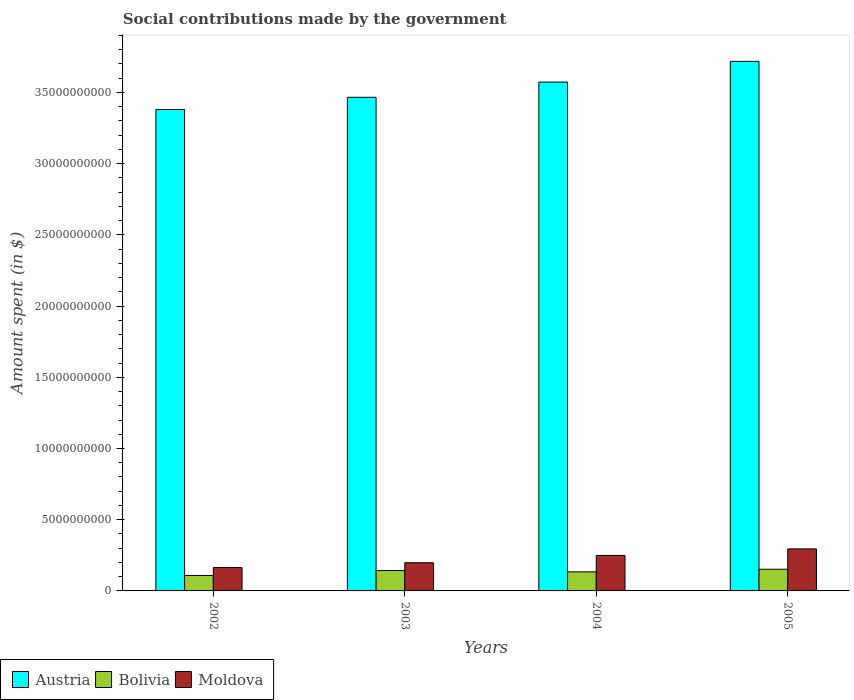How many different coloured bars are there?
Offer a terse response. 3. How many bars are there on the 1st tick from the left?
Make the answer very short. 3. In how many cases, is the number of bars for a given year not equal to the number of legend labels?
Give a very brief answer. 0. What is the amount spent on social contributions in Moldova in 2004?
Give a very brief answer. 2.49e+09. Across all years, what is the maximum amount spent on social contributions in Austria?
Your answer should be very brief. 3.72e+1. Across all years, what is the minimum amount spent on social contributions in Bolivia?
Offer a terse response. 1.08e+09. In which year was the amount spent on social contributions in Bolivia maximum?
Your answer should be compact. 2005. In which year was the amount spent on social contributions in Austria minimum?
Offer a very short reply. 2002. What is the total amount spent on social contributions in Bolivia in the graph?
Keep it short and to the point. 5.38e+09. What is the difference between the amount spent on social contributions in Moldova in 2004 and that in 2005?
Make the answer very short. -4.57e+08. What is the difference between the amount spent on social contributions in Austria in 2003 and the amount spent on social contributions in Bolivia in 2005?
Offer a very short reply. 3.31e+1. What is the average amount spent on social contributions in Moldova per year?
Offer a very short reply. 2.27e+09. In the year 2003, what is the difference between the amount spent on social contributions in Austria and amount spent on social contributions in Moldova?
Offer a terse response. 3.27e+1. What is the ratio of the amount spent on social contributions in Austria in 2002 to that in 2003?
Your response must be concise. 0.98. What is the difference between the highest and the second highest amount spent on social contributions in Bolivia?
Ensure brevity in your answer.  9.23e+07. What is the difference between the highest and the lowest amount spent on social contributions in Moldova?
Provide a succinct answer. 1.31e+09. In how many years, is the amount spent on social contributions in Austria greater than the average amount spent on social contributions in Austria taken over all years?
Offer a very short reply. 2. What does the 1st bar from the right in 2003 represents?
Your answer should be very brief. Moldova. Are all the bars in the graph horizontal?
Your answer should be compact. No. Are the values on the major ticks of Y-axis written in scientific E-notation?
Give a very brief answer. No. Where does the legend appear in the graph?
Offer a very short reply. Bottom left. What is the title of the graph?
Your response must be concise. Social contributions made by the government. What is the label or title of the X-axis?
Provide a succinct answer. Years. What is the label or title of the Y-axis?
Make the answer very short. Amount spent (in $). What is the Amount spent (in $) of Austria in 2002?
Ensure brevity in your answer.  3.38e+1. What is the Amount spent (in $) of Bolivia in 2002?
Your answer should be compact. 1.08e+09. What is the Amount spent (in $) in Moldova in 2002?
Offer a terse response. 1.64e+09. What is the Amount spent (in $) in Austria in 2003?
Make the answer very short. 3.47e+1. What is the Amount spent (in $) in Bolivia in 2003?
Your answer should be compact. 1.43e+09. What is the Amount spent (in $) in Moldova in 2003?
Provide a succinct answer. 1.98e+09. What is the Amount spent (in $) in Austria in 2004?
Provide a succinct answer. 3.57e+1. What is the Amount spent (in $) in Bolivia in 2004?
Offer a very short reply. 1.34e+09. What is the Amount spent (in $) of Moldova in 2004?
Give a very brief answer. 2.49e+09. What is the Amount spent (in $) of Austria in 2005?
Provide a succinct answer. 3.72e+1. What is the Amount spent (in $) of Bolivia in 2005?
Give a very brief answer. 1.52e+09. What is the Amount spent (in $) in Moldova in 2005?
Keep it short and to the point. 2.95e+09. Across all years, what is the maximum Amount spent (in $) of Austria?
Keep it short and to the point. 3.72e+1. Across all years, what is the maximum Amount spent (in $) in Bolivia?
Offer a terse response. 1.52e+09. Across all years, what is the maximum Amount spent (in $) of Moldova?
Ensure brevity in your answer.  2.95e+09. Across all years, what is the minimum Amount spent (in $) of Austria?
Offer a terse response. 3.38e+1. Across all years, what is the minimum Amount spent (in $) in Bolivia?
Your answer should be compact. 1.08e+09. Across all years, what is the minimum Amount spent (in $) in Moldova?
Offer a terse response. 1.64e+09. What is the total Amount spent (in $) of Austria in the graph?
Your answer should be very brief. 1.41e+11. What is the total Amount spent (in $) in Bolivia in the graph?
Ensure brevity in your answer.  5.38e+09. What is the total Amount spent (in $) in Moldova in the graph?
Provide a short and direct response. 9.06e+09. What is the difference between the Amount spent (in $) of Austria in 2002 and that in 2003?
Your answer should be compact. -8.56e+08. What is the difference between the Amount spent (in $) of Bolivia in 2002 and that in 2003?
Your response must be concise. -3.46e+08. What is the difference between the Amount spent (in $) of Moldova in 2002 and that in 2003?
Your answer should be very brief. -3.34e+08. What is the difference between the Amount spent (in $) of Austria in 2002 and that in 2004?
Give a very brief answer. -1.92e+09. What is the difference between the Amount spent (in $) of Bolivia in 2002 and that in 2004?
Your answer should be very brief. -2.54e+08. What is the difference between the Amount spent (in $) of Moldova in 2002 and that in 2004?
Offer a terse response. -8.49e+08. What is the difference between the Amount spent (in $) in Austria in 2002 and that in 2005?
Give a very brief answer. -3.38e+09. What is the difference between the Amount spent (in $) in Bolivia in 2002 and that in 2005?
Your answer should be compact. -4.39e+08. What is the difference between the Amount spent (in $) in Moldova in 2002 and that in 2005?
Offer a terse response. -1.31e+09. What is the difference between the Amount spent (in $) of Austria in 2003 and that in 2004?
Offer a very short reply. -1.07e+09. What is the difference between the Amount spent (in $) of Bolivia in 2003 and that in 2004?
Your answer should be very brief. 9.22e+07. What is the difference between the Amount spent (in $) in Moldova in 2003 and that in 2004?
Your answer should be compact. -5.14e+08. What is the difference between the Amount spent (in $) of Austria in 2003 and that in 2005?
Ensure brevity in your answer.  -2.52e+09. What is the difference between the Amount spent (in $) of Bolivia in 2003 and that in 2005?
Provide a short and direct response. -9.23e+07. What is the difference between the Amount spent (in $) in Moldova in 2003 and that in 2005?
Your answer should be compact. -9.71e+08. What is the difference between the Amount spent (in $) of Austria in 2004 and that in 2005?
Your answer should be compact. -1.45e+09. What is the difference between the Amount spent (in $) of Bolivia in 2004 and that in 2005?
Provide a short and direct response. -1.84e+08. What is the difference between the Amount spent (in $) of Moldova in 2004 and that in 2005?
Ensure brevity in your answer.  -4.57e+08. What is the difference between the Amount spent (in $) of Austria in 2002 and the Amount spent (in $) of Bolivia in 2003?
Your answer should be compact. 3.24e+1. What is the difference between the Amount spent (in $) of Austria in 2002 and the Amount spent (in $) of Moldova in 2003?
Make the answer very short. 3.18e+1. What is the difference between the Amount spent (in $) of Bolivia in 2002 and the Amount spent (in $) of Moldova in 2003?
Provide a short and direct response. -8.94e+08. What is the difference between the Amount spent (in $) of Austria in 2002 and the Amount spent (in $) of Bolivia in 2004?
Your answer should be very brief. 3.25e+1. What is the difference between the Amount spent (in $) in Austria in 2002 and the Amount spent (in $) in Moldova in 2004?
Keep it short and to the point. 3.13e+1. What is the difference between the Amount spent (in $) of Bolivia in 2002 and the Amount spent (in $) of Moldova in 2004?
Provide a succinct answer. -1.41e+09. What is the difference between the Amount spent (in $) of Austria in 2002 and the Amount spent (in $) of Bolivia in 2005?
Provide a succinct answer. 3.23e+1. What is the difference between the Amount spent (in $) in Austria in 2002 and the Amount spent (in $) in Moldova in 2005?
Keep it short and to the point. 3.09e+1. What is the difference between the Amount spent (in $) in Bolivia in 2002 and the Amount spent (in $) in Moldova in 2005?
Provide a succinct answer. -1.86e+09. What is the difference between the Amount spent (in $) of Austria in 2003 and the Amount spent (in $) of Bolivia in 2004?
Make the answer very short. 3.33e+1. What is the difference between the Amount spent (in $) in Austria in 2003 and the Amount spent (in $) in Moldova in 2004?
Provide a succinct answer. 3.22e+1. What is the difference between the Amount spent (in $) of Bolivia in 2003 and the Amount spent (in $) of Moldova in 2004?
Your answer should be compact. -1.06e+09. What is the difference between the Amount spent (in $) in Austria in 2003 and the Amount spent (in $) in Bolivia in 2005?
Your answer should be very brief. 3.31e+1. What is the difference between the Amount spent (in $) of Austria in 2003 and the Amount spent (in $) of Moldova in 2005?
Ensure brevity in your answer.  3.17e+1. What is the difference between the Amount spent (in $) of Bolivia in 2003 and the Amount spent (in $) of Moldova in 2005?
Your response must be concise. -1.52e+09. What is the difference between the Amount spent (in $) of Austria in 2004 and the Amount spent (in $) of Bolivia in 2005?
Give a very brief answer. 3.42e+1. What is the difference between the Amount spent (in $) of Austria in 2004 and the Amount spent (in $) of Moldova in 2005?
Offer a terse response. 3.28e+1. What is the difference between the Amount spent (in $) in Bolivia in 2004 and the Amount spent (in $) in Moldova in 2005?
Keep it short and to the point. -1.61e+09. What is the average Amount spent (in $) in Austria per year?
Make the answer very short. 3.53e+1. What is the average Amount spent (in $) of Bolivia per year?
Provide a short and direct response. 1.34e+09. What is the average Amount spent (in $) in Moldova per year?
Make the answer very short. 2.27e+09. In the year 2002, what is the difference between the Amount spent (in $) in Austria and Amount spent (in $) in Bolivia?
Offer a very short reply. 3.27e+1. In the year 2002, what is the difference between the Amount spent (in $) in Austria and Amount spent (in $) in Moldova?
Your answer should be compact. 3.22e+1. In the year 2002, what is the difference between the Amount spent (in $) in Bolivia and Amount spent (in $) in Moldova?
Provide a short and direct response. -5.59e+08. In the year 2003, what is the difference between the Amount spent (in $) in Austria and Amount spent (in $) in Bolivia?
Offer a terse response. 3.32e+1. In the year 2003, what is the difference between the Amount spent (in $) in Austria and Amount spent (in $) in Moldova?
Make the answer very short. 3.27e+1. In the year 2003, what is the difference between the Amount spent (in $) in Bolivia and Amount spent (in $) in Moldova?
Make the answer very short. -5.47e+08. In the year 2004, what is the difference between the Amount spent (in $) of Austria and Amount spent (in $) of Bolivia?
Your response must be concise. 3.44e+1. In the year 2004, what is the difference between the Amount spent (in $) in Austria and Amount spent (in $) in Moldova?
Your answer should be compact. 3.32e+1. In the year 2004, what is the difference between the Amount spent (in $) of Bolivia and Amount spent (in $) of Moldova?
Make the answer very short. -1.15e+09. In the year 2005, what is the difference between the Amount spent (in $) of Austria and Amount spent (in $) of Bolivia?
Make the answer very short. 3.57e+1. In the year 2005, what is the difference between the Amount spent (in $) in Austria and Amount spent (in $) in Moldova?
Make the answer very short. 3.42e+1. In the year 2005, what is the difference between the Amount spent (in $) in Bolivia and Amount spent (in $) in Moldova?
Make the answer very short. -1.43e+09. What is the ratio of the Amount spent (in $) in Austria in 2002 to that in 2003?
Give a very brief answer. 0.98. What is the ratio of the Amount spent (in $) in Bolivia in 2002 to that in 2003?
Your answer should be very brief. 0.76. What is the ratio of the Amount spent (in $) in Moldova in 2002 to that in 2003?
Ensure brevity in your answer.  0.83. What is the ratio of the Amount spent (in $) of Austria in 2002 to that in 2004?
Your response must be concise. 0.95. What is the ratio of the Amount spent (in $) in Bolivia in 2002 to that in 2004?
Provide a short and direct response. 0.81. What is the ratio of the Amount spent (in $) in Moldova in 2002 to that in 2004?
Offer a terse response. 0.66. What is the ratio of the Amount spent (in $) in Bolivia in 2002 to that in 2005?
Keep it short and to the point. 0.71. What is the ratio of the Amount spent (in $) of Moldova in 2002 to that in 2005?
Make the answer very short. 0.56. What is the ratio of the Amount spent (in $) in Austria in 2003 to that in 2004?
Your answer should be very brief. 0.97. What is the ratio of the Amount spent (in $) in Bolivia in 2003 to that in 2004?
Provide a short and direct response. 1.07. What is the ratio of the Amount spent (in $) of Moldova in 2003 to that in 2004?
Provide a succinct answer. 0.79. What is the ratio of the Amount spent (in $) of Austria in 2003 to that in 2005?
Offer a terse response. 0.93. What is the ratio of the Amount spent (in $) in Bolivia in 2003 to that in 2005?
Provide a short and direct response. 0.94. What is the ratio of the Amount spent (in $) of Moldova in 2003 to that in 2005?
Your response must be concise. 0.67. What is the ratio of the Amount spent (in $) of Austria in 2004 to that in 2005?
Ensure brevity in your answer.  0.96. What is the ratio of the Amount spent (in $) of Bolivia in 2004 to that in 2005?
Keep it short and to the point. 0.88. What is the ratio of the Amount spent (in $) of Moldova in 2004 to that in 2005?
Give a very brief answer. 0.85. What is the difference between the highest and the second highest Amount spent (in $) of Austria?
Your answer should be very brief. 1.45e+09. What is the difference between the highest and the second highest Amount spent (in $) in Bolivia?
Offer a terse response. 9.23e+07. What is the difference between the highest and the second highest Amount spent (in $) in Moldova?
Provide a short and direct response. 4.57e+08. What is the difference between the highest and the lowest Amount spent (in $) in Austria?
Your response must be concise. 3.38e+09. What is the difference between the highest and the lowest Amount spent (in $) of Bolivia?
Give a very brief answer. 4.39e+08. What is the difference between the highest and the lowest Amount spent (in $) of Moldova?
Your response must be concise. 1.31e+09. 